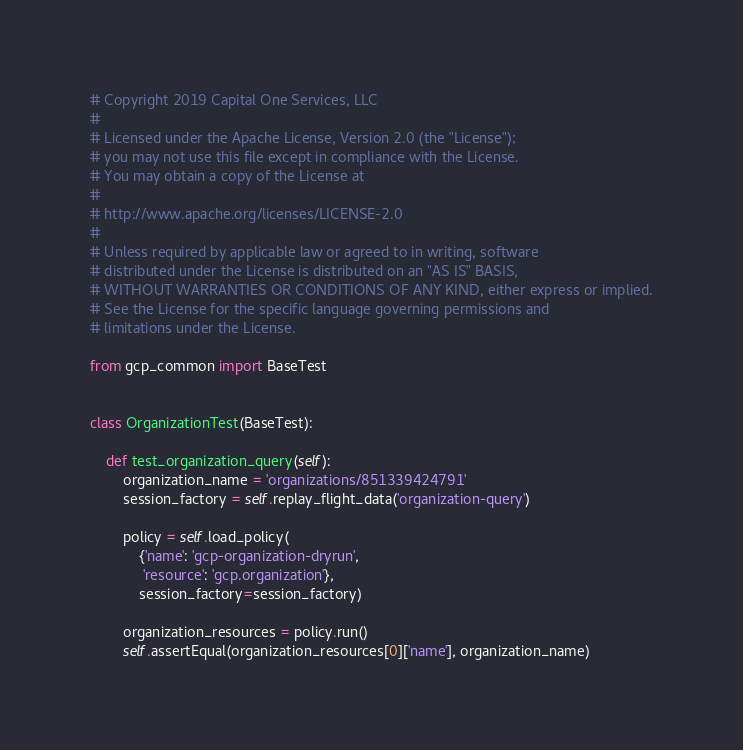<code> <loc_0><loc_0><loc_500><loc_500><_Python_># Copyright 2019 Capital One Services, LLC
#
# Licensed under the Apache License, Version 2.0 (the "License");
# you may not use this file except in compliance with the License.
# You may obtain a copy of the License at
#
# http://www.apache.org/licenses/LICENSE-2.0
#
# Unless required by applicable law or agreed to in writing, software
# distributed under the License is distributed on an "AS IS" BASIS,
# WITHOUT WARRANTIES OR CONDITIONS OF ANY KIND, either express or implied.
# See the License for the specific language governing permissions and
# limitations under the License.

from gcp_common import BaseTest


class OrganizationTest(BaseTest):

    def test_organization_query(self):
        organization_name = 'organizations/851339424791'
        session_factory = self.replay_flight_data('organization-query')

        policy = self.load_policy(
            {'name': 'gcp-organization-dryrun',
             'resource': 'gcp.organization'},
            session_factory=session_factory)

        organization_resources = policy.run()
        self.assertEqual(organization_resources[0]['name'], organization_name)
</code> 